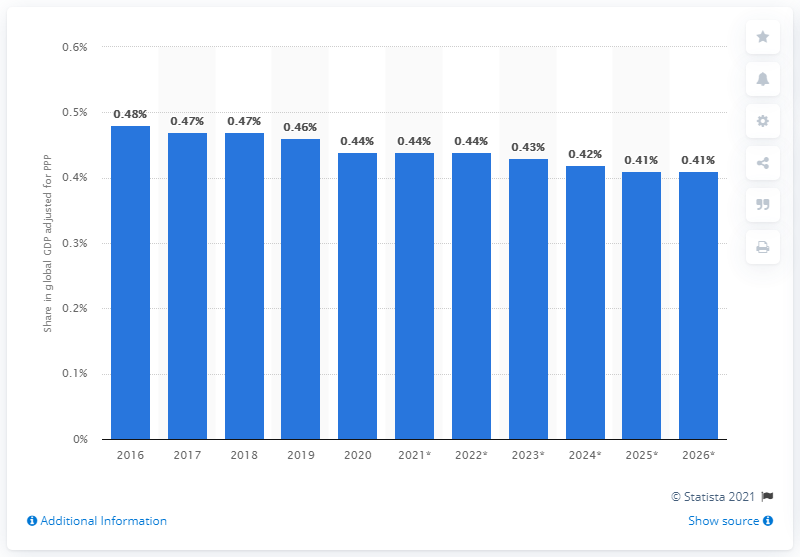Identify some key points in this picture. In 2020, Belgium's share of the global gross domestic product, adjusted for purchasing power parity, was 0.44%. 